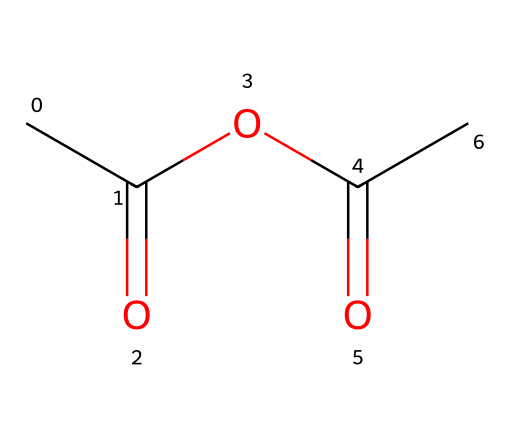How many carbon atoms are in acetic anhydride? The SMILES representation shows two carbonyl groups (C=O) and three additional carbon atoms, making a total of 4 carbon atoms.
Answer: four What type of functional groups are present in acetic anhydride? Anhydrides contain carbonyl groups (C=O) bonded to an alkoxy group (C-O). In this structure, there are two carbonyl groups and one ether-like bond (C-O).
Answer: anhydride What is the molecular formula of acetic anhydride? From the structure, we can identify 4 carbon atoms, 6 hydrogen atoms, and 2 oxygen atoms, making the molecular formula C4H6O3.
Answer: C4H6O3 What is the degree of unsaturation in acetic anhydride? The degree of unsaturation can be calculated by considering the number of rings and multiple bonds. Here, the two carbonyl groups contribute to two degrees of unsaturation, while the structure has no rings.
Answer: two How many oxygen atoms are present in acetic anhydride? The SMILES representation indicates there are two oxygen atoms located in the two carbonyl groups, totaling to 2 oxygen atoms.
Answer: two What characteristic does the presence of two carbonyl groups impart to acetic anhydride? The two carbonyl groups contribute to the reactivity of the compound, making it an effective acylating agent in chemical reactions due to their electrophilic nature.
Answer: reactivity 